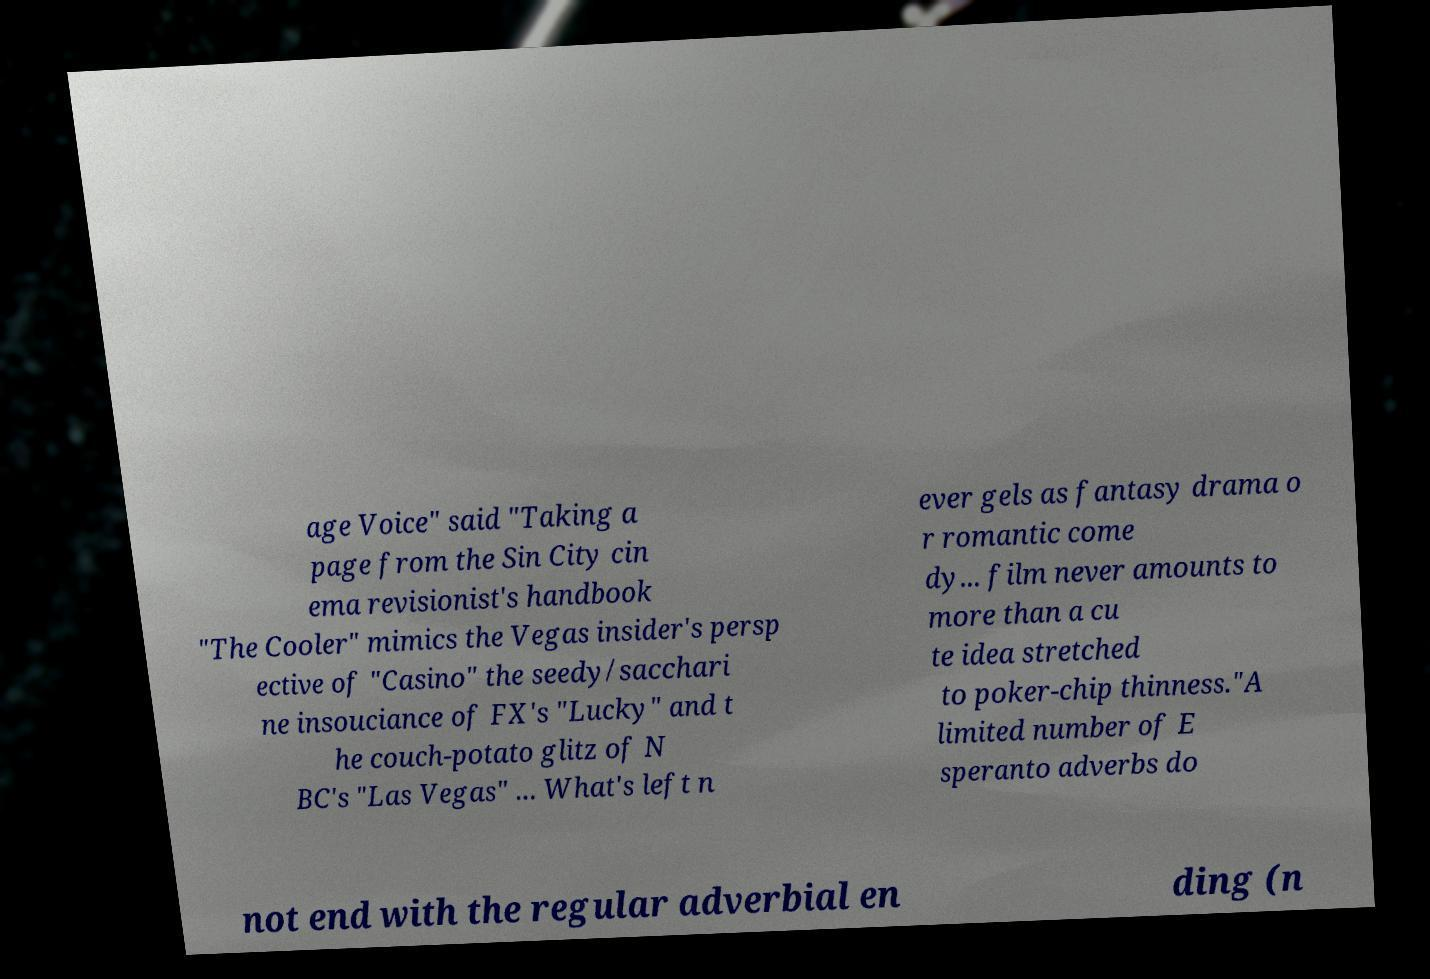I need the written content from this picture converted into text. Can you do that? age Voice" said "Taking a page from the Sin City cin ema revisionist's handbook "The Cooler" mimics the Vegas insider's persp ective of "Casino" the seedy/sacchari ne insouciance of FX's "Lucky" and t he couch-potato glitz of N BC's "Las Vegas" ... What's left n ever gels as fantasy drama o r romantic come dy... film never amounts to more than a cu te idea stretched to poker-chip thinness."A limited number of E speranto adverbs do not end with the regular adverbial en ding (n 